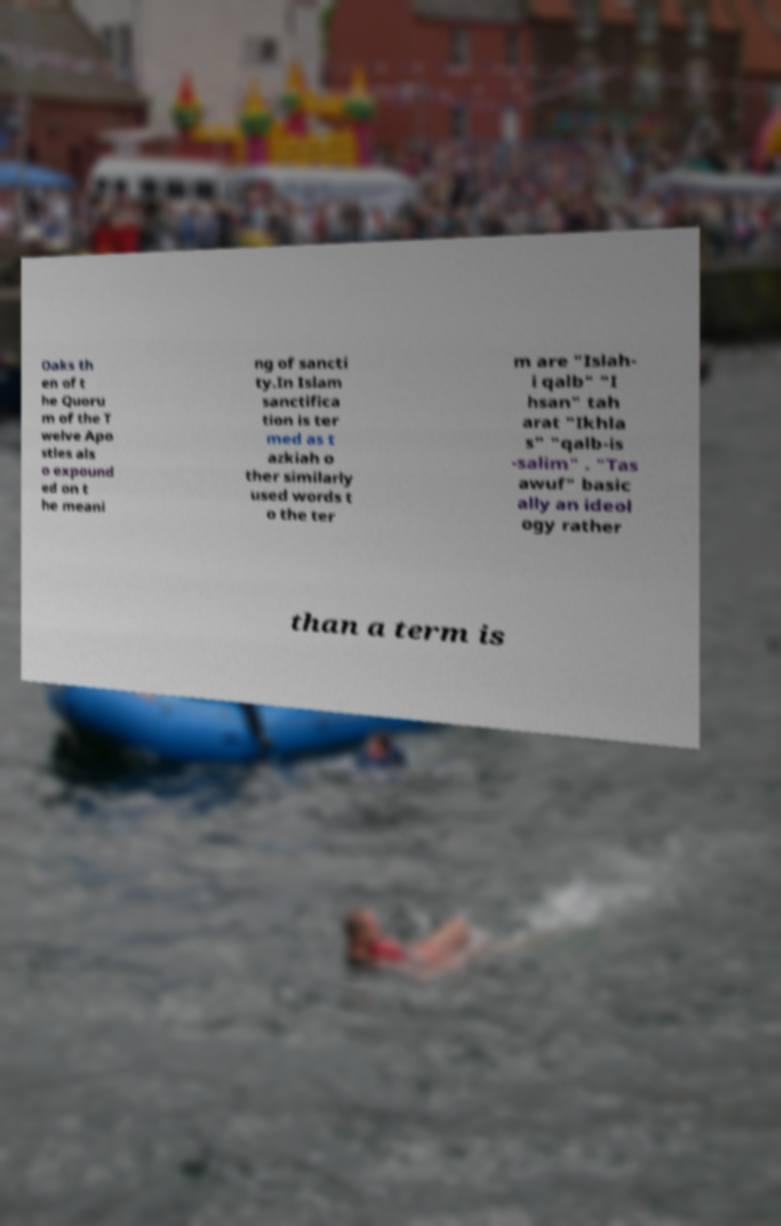For documentation purposes, I need the text within this image transcribed. Could you provide that? Oaks th en of t he Quoru m of the T welve Apo stles als o expound ed on t he meani ng of sancti ty.In Islam sanctifica tion is ter med as t azkiah o ther similarly used words t o the ter m are "Islah- i qalb" "I hsan" tah arat "Ikhla s" "qalb-is -salim" . "Tas awuf" basic ally an ideol ogy rather than a term is 